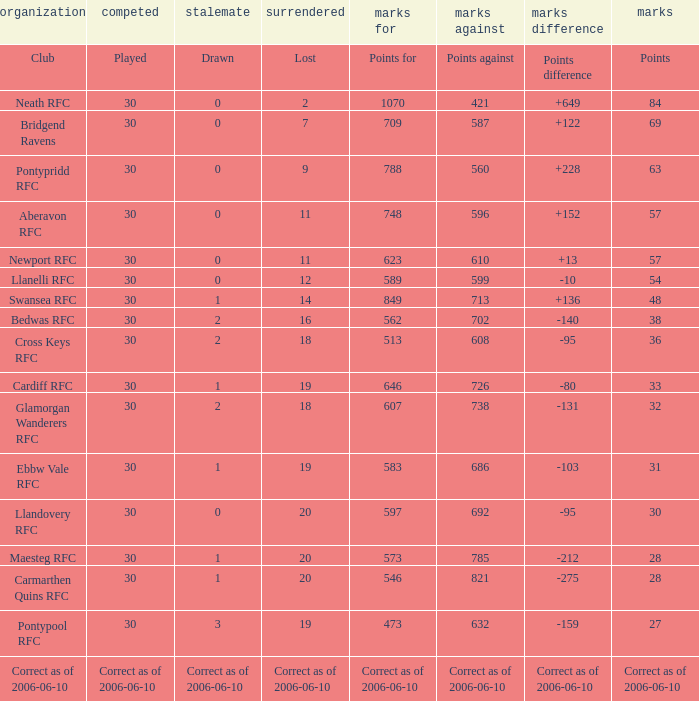What is Points For, when Points is "63"? 788.0. 